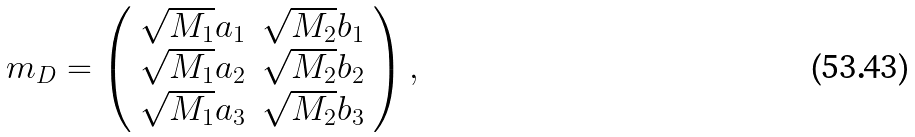Convert formula to latex. <formula><loc_0><loc_0><loc_500><loc_500>m _ { D } = \left ( \begin{array} { c c } \sqrt { M _ { 1 } } a _ { 1 } & \sqrt { M _ { 2 } } b _ { 1 } \\ \sqrt { M _ { 1 } } a _ { 2 } & \sqrt { M _ { 2 } } b _ { 2 } \\ \sqrt { M _ { 1 } } a _ { 3 } & \sqrt { M _ { 2 } } b _ { 3 } \end{array} \right ) ,</formula> 